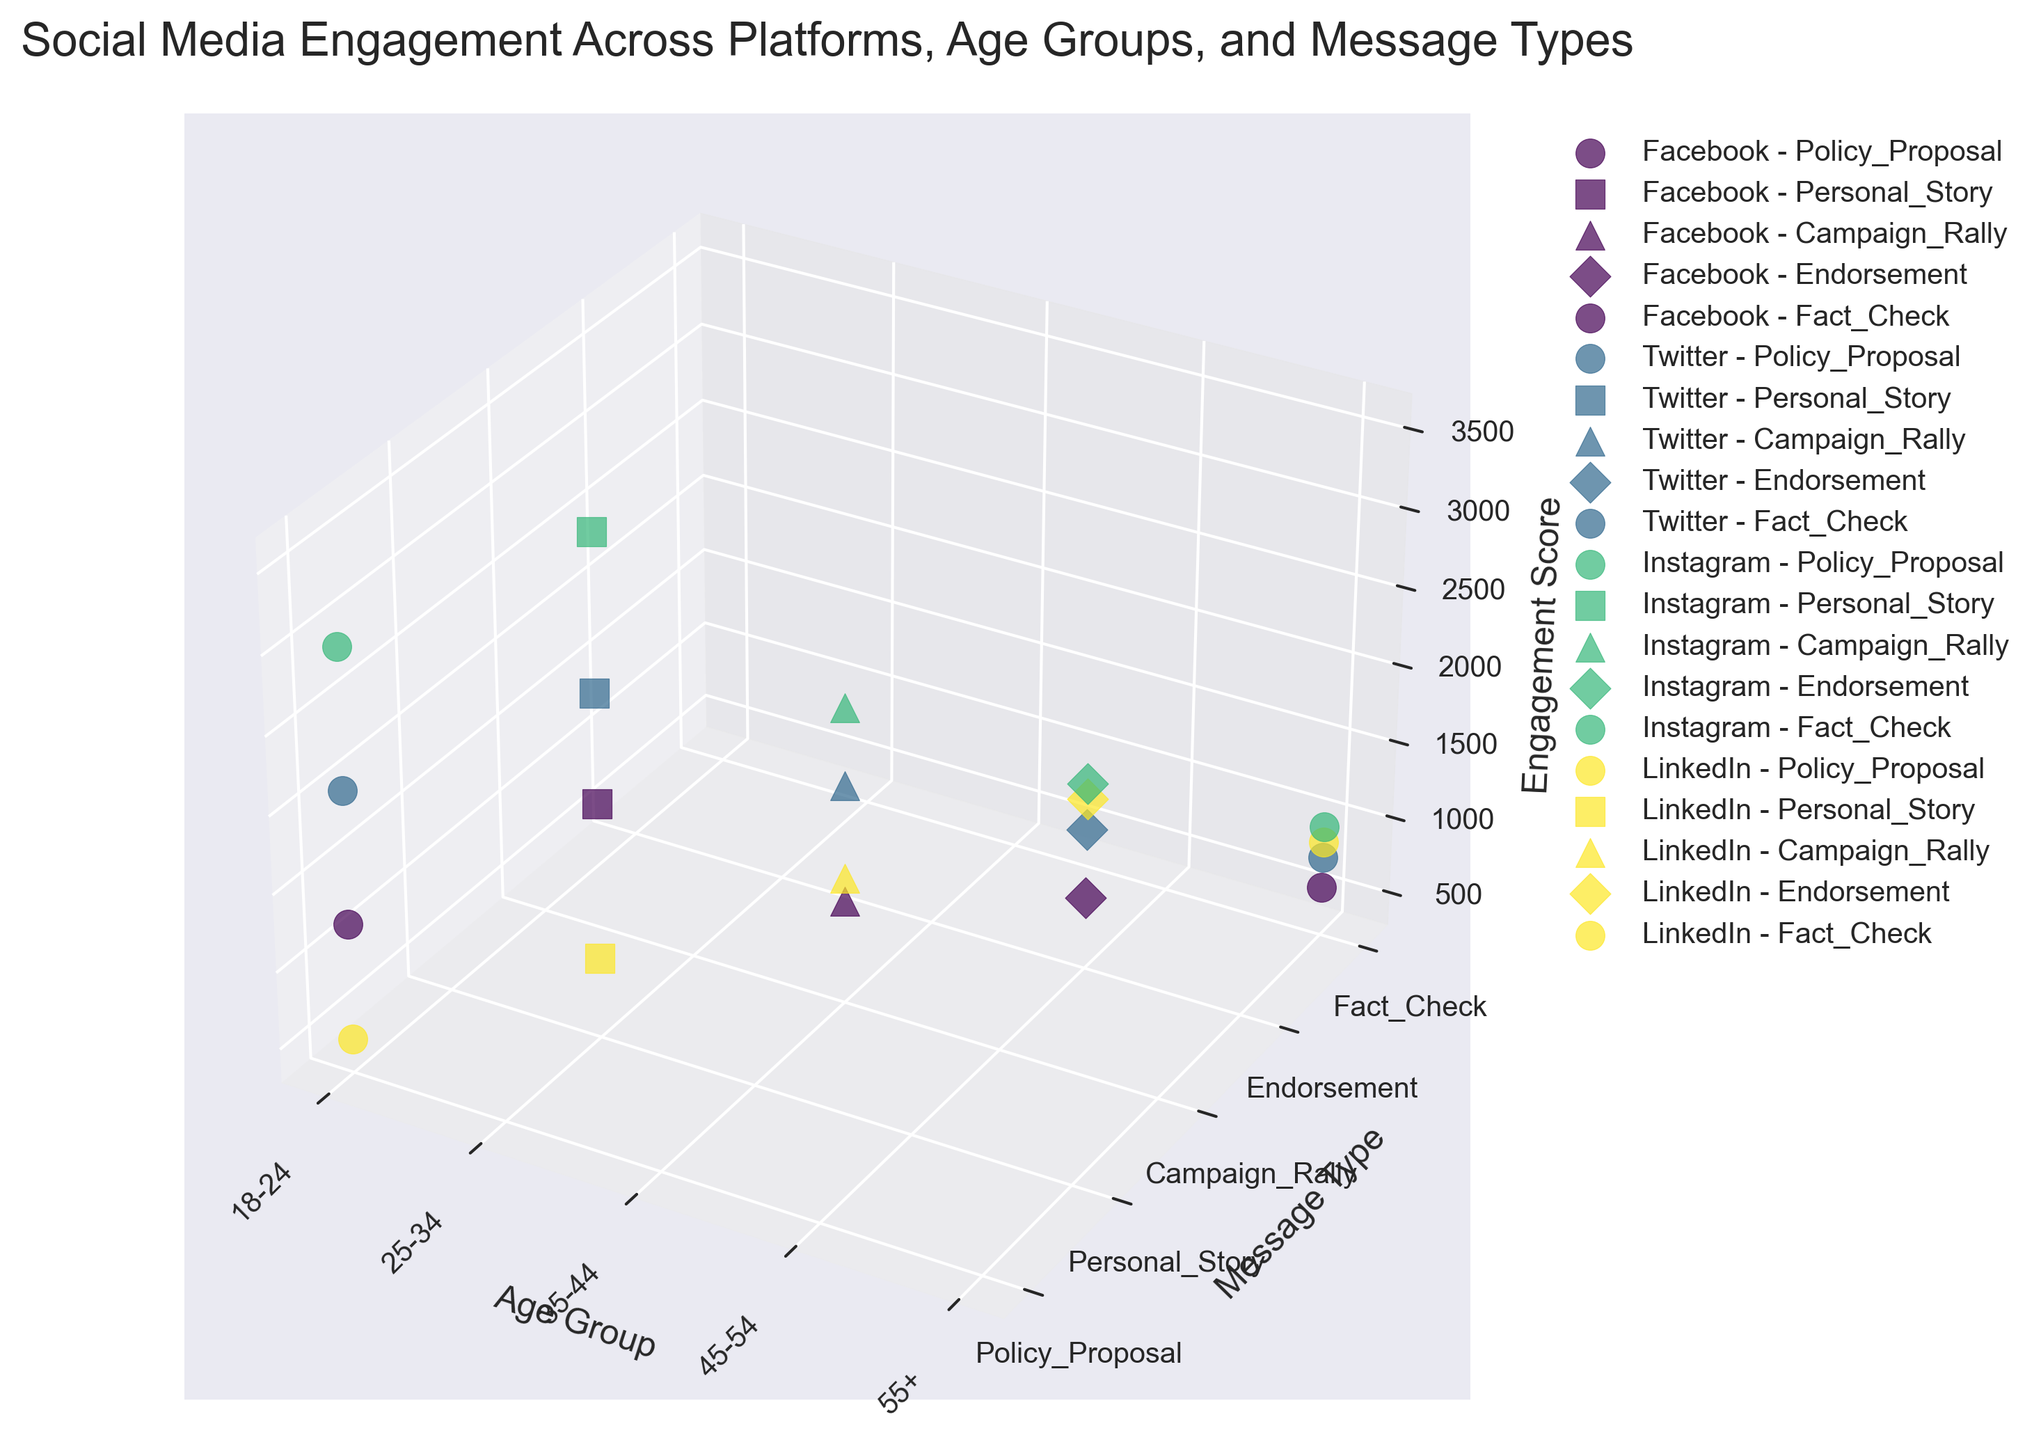What is the title of the plot? The title of the plot is included at the top of the figure in a larger font size. It provides an immediate understanding of what the plot represents. The title is usually straightforward to read and can be found without any computations.
Answer: Social Media Engagement Across Platforms, Age Groups, and Message Types What does the Z-axis represent in the plot? The Z-axis in the plot represents one of the main variables being visualized. It is indicated by the axis label, usually positioned parallel to the axis.
Answer: Engagement Score Which platform has the highest engagement score for the message type "Policy_Proposal"? To answer this, locate the label "Policy_Proposal" on the Y-axis. Then, identify the different colors and markers representing each platform. Compare the Z-axis values for "Policy_Proposal" across all platforms.
Answer: Instagram In the age group "25-34", which message type has the highest engagement score on Facebook? First, identify the marker representing Facebook. Next, find the section for the age group "25-34" in the plot. Compare the Z-axis values for different message types within this age group for the Facebook marker.
Answer: Personal_Story What is the difference in engagement score between "Personal_Story" on Twitter and Instagram for the age group "25-34"? Locate the markers for "Personal_Story" on both Twitter and Instagram. Find the Z-axis values for these markers in the age group "25-34". Subtract the Twitter value from the Instagram value to find the difference.
Answer: 1000 Which age group has the highest overall engagement score on LinkedIn? Look for the LinkedIn markers in the plot. Compare the Z-axis values for all message types within each age group for LinkedIn, and identify which age group has the highest value.
Answer: 45-54 For which platform and age group combination is the engagement score the lowest for "Fact_Check"? Locate the "Fact_Check" section on the Y-axis. Compare the Z-axis values for different platforms in each age group. Identify the combination with the lowest engagement score.
Answer: Facebook, 55+ Between "Campaign_Rally" and "Endorsement" on Instagram, which message type has higher engagement for the age group "35-44"? Find the Instagram markers in the age group "35-44". Compare the Z-axis values for "Campaign_Rally" and "Endorsement" to see which is higher.
Answer: Campaign_Rally What is the average engagement score on Twitter for the age groups "35-44" and "45-54"? Identify the Z-axis values for Twitter in the age groups "35-44" and "45-54". Add these values together and divide by 2 to get the average.
Answer: 1450 How does the engagement score for "Personal_Story" on Facebook compare to Twitter for the age group "25-34"? Find the Facebook and Twitter markers for "Personal_Story" in the age group "25-34". Compare their Z-axis values to see which is higher.
Answer: Twitter is higher 